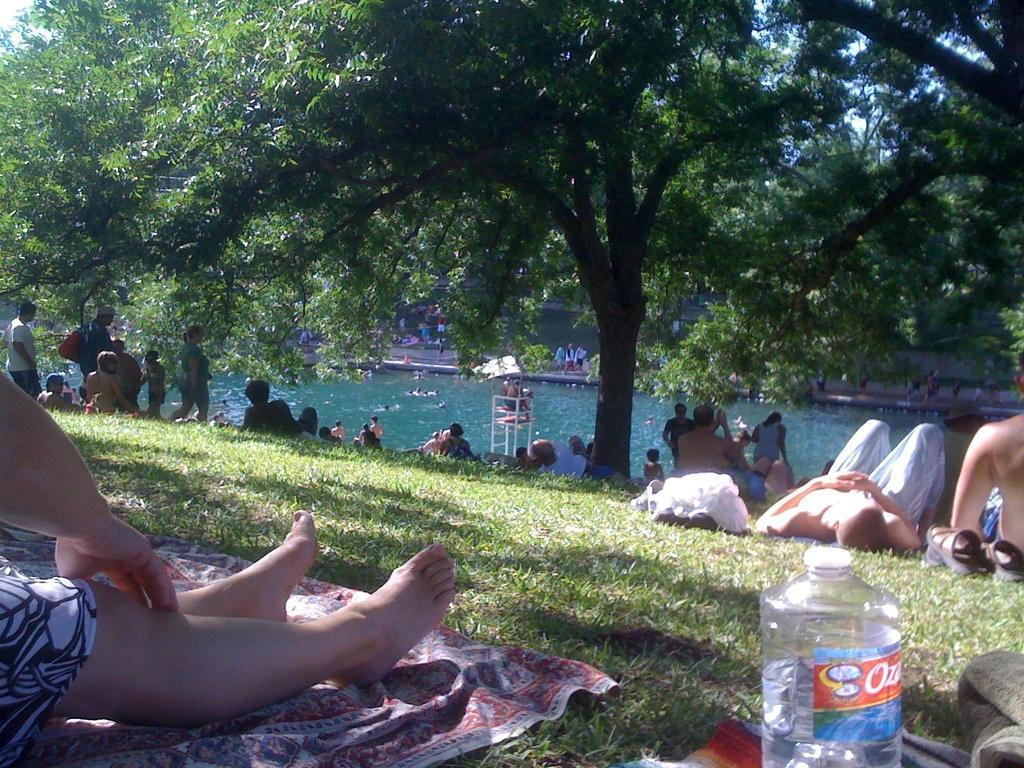Can you describe this image briefly? In this image we can see some person's resting on ground and there is some grass and some objects on floor and in the background of the image there are some trees and water. 